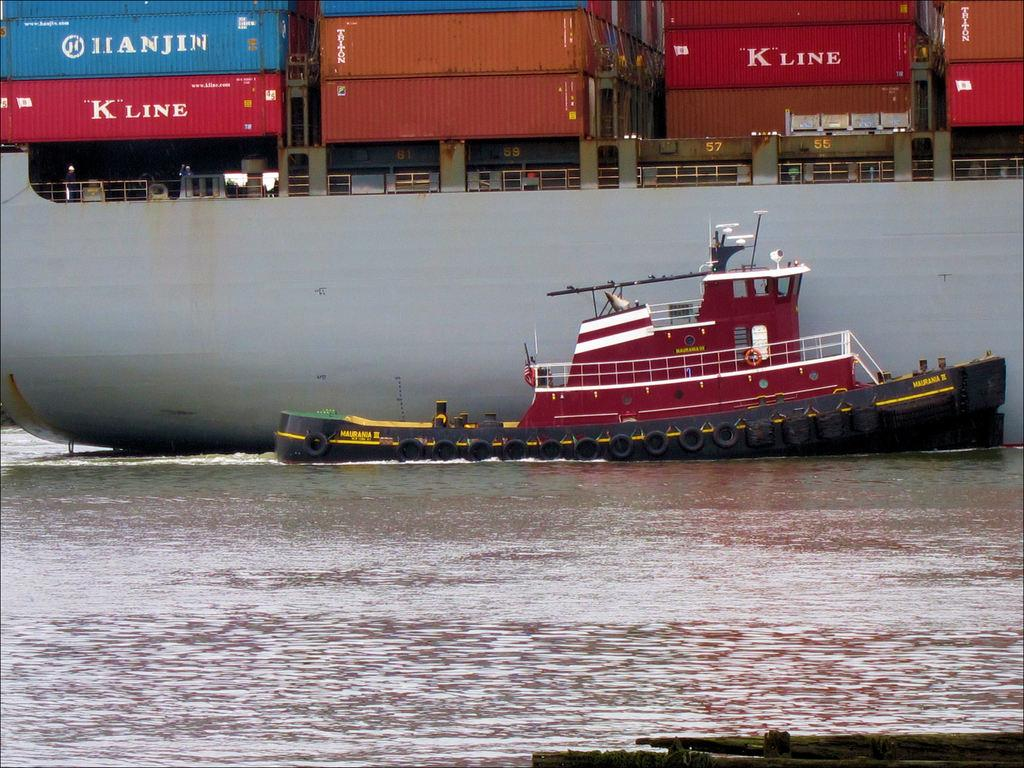What can be seen in the image that is used for transportation on water? There are boats in the image. What can be found inside the boats in the image? There are colorful containers in the ship. What is the primary substance visible in the image? There is water visible in the image. How many girls can be seen expressing their hate for trains in the image? There are no girls or trains present in the image. 